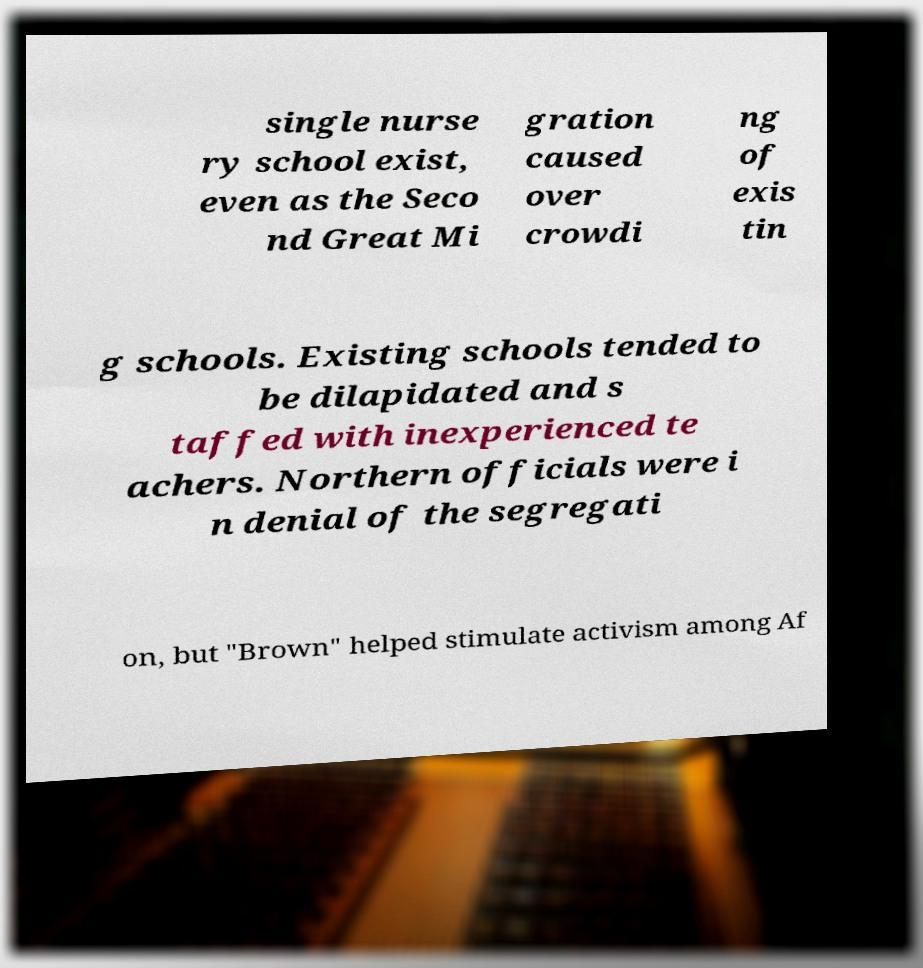For documentation purposes, I need the text within this image transcribed. Could you provide that? single nurse ry school exist, even as the Seco nd Great Mi gration caused over crowdi ng of exis tin g schools. Existing schools tended to be dilapidated and s taffed with inexperienced te achers. Northern officials were i n denial of the segregati on, but "Brown" helped stimulate activism among Af 